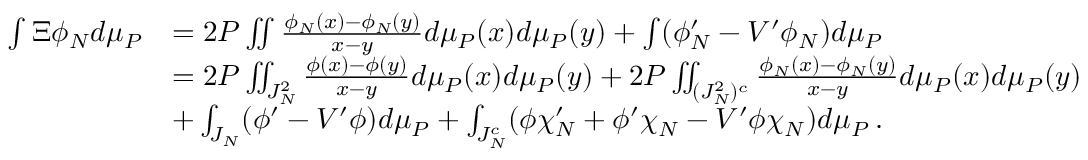Convert formula to latex. <formula><loc_0><loc_0><loc_500><loc_500>\begin{array} { r l } { \int \Xi \phi _ { N } d \mu _ { P } } & { = 2 P \iint \frac { \phi _ { N } ( x ) - \phi _ { N } ( y ) } { x - y } d \mu _ { P } ( x ) d \mu _ { P } ( y ) + \int ( \phi _ { N } ^ { \prime } - V ^ { \prime } \phi _ { N } ) d \mu _ { P } } \\ & { = 2 P \iint _ { J _ { N } ^ { 2 } } \frac { \phi ( x ) - \phi ( y ) } { x - y } d \mu _ { P } ( x ) d \mu _ { P } ( y ) + 2 P \iint _ { ( J _ { N } ^ { 2 } ) ^ { c } } \frac { \phi _ { N } ( x ) - \phi _ { N } ( y ) } { x - y } d \mu _ { P } ( x ) d \mu _ { P } ( y ) } \\ & { + \int _ { J _ { N } } ( \phi ^ { \prime } - V ^ { \prime } \phi ) d \mu _ { P } + \int _ { J _ { N } ^ { c } } ( \phi \chi _ { N } ^ { \prime } + \phi ^ { \prime } \chi _ { N } - V ^ { \prime } \phi \chi _ { N } ) d \mu _ { P } \, . } \end{array}</formula> 